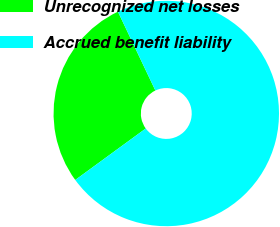Convert chart to OTSL. <chart><loc_0><loc_0><loc_500><loc_500><pie_chart><fcel>Unrecognized net losses<fcel>Accrued benefit liability<nl><fcel>27.98%<fcel>72.02%<nl></chart> 